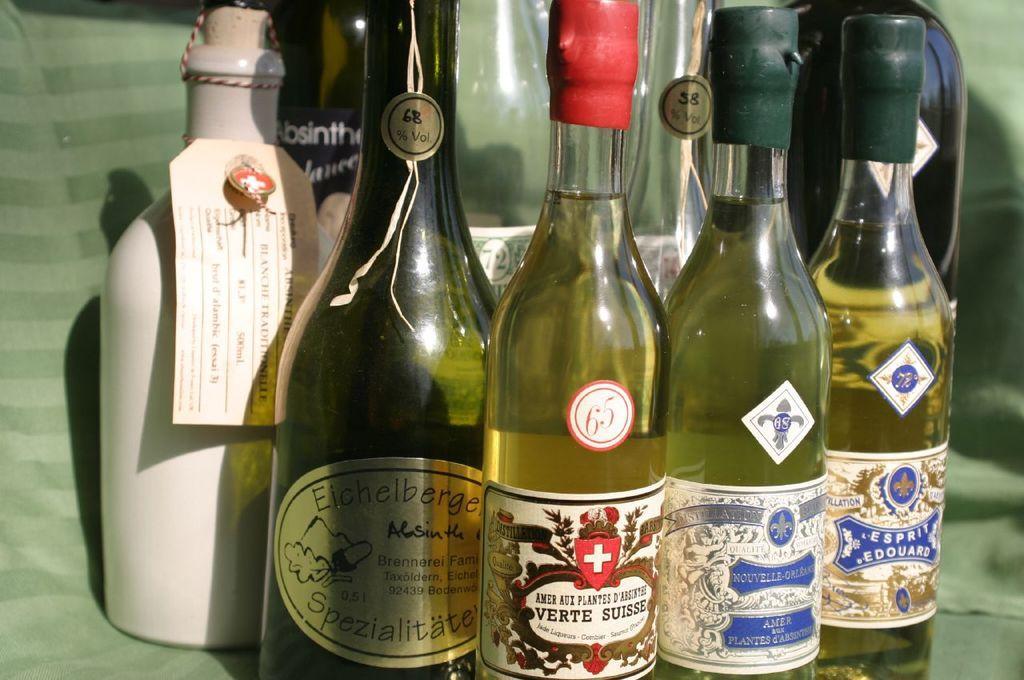Could you give a brief overview of what you see in this image? In the image we can see few bottles on which it is labelled as 'SPECIALIZED', which are placed on green color mat. 